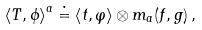<formula> <loc_0><loc_0><loc_500><loc_500>\left < T , \phi \right > ^ { a } \doteq \left < t , \varphi \right > \otimes m _ { a } ( f , g ) \, ,</formula> 